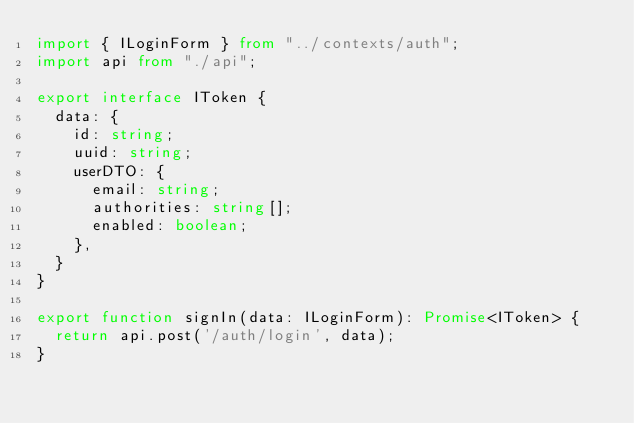<code> <loc_0><loc_0><loc_500><loc_500><_TypeScript_>import { ILoginForm } from "../contexts/auth";
import api from "./api";

export interface IToken {
  data: {
    id: string;
    uuid: string;
    userDTO: {
      email: string;
      authorities: string[];
      enabled: boolean;
    },
  }
}

export function signIn(data: ILoginForm): Promise<IToken> {
  return api.post('/auth/login', data);
}</code> 